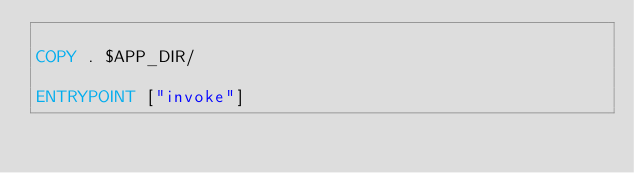<code> <loc_0><loc_0><loc_500><loc_500><_Dockerfile_>
COPY . $APP_DIR/

ENTRYPOINT ["invoke"]
</code> 